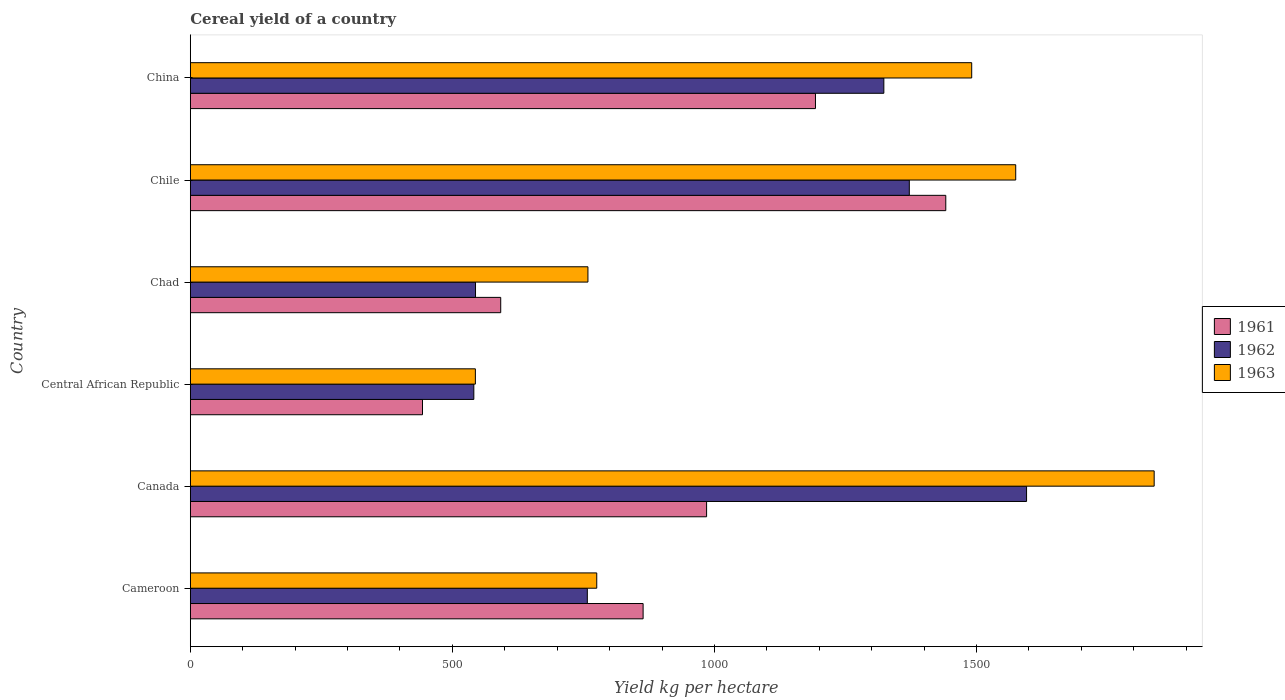How many different coloured bars are there?
Offer a very short reply. 3. How many groups of bars are there?
Your response must be concise. 6. Are the number of bars per tick equal to the number of legend labels?
Your response must be concise. Yes. How many bars are there on the 5th tick from the top?
Offer a terse response. 3. What is the label of the 3rd group of bars from the top?
Make the answer very short. Chad. What is the total cereal yield in 1961 in Chile?
Make the answer very short. 1441.31. Across all countries, what is the maximum total cereal yield in 1961?
Make the answer very short. 1441.31. Across all countries, what is the minimum total cereal yield in 1961?
Give a very brief answer. 443. In which country was the total cereal yield in 1962 minimum?
Your answer should be compact. Central African Republic. What is the total total cereal yield in 1963 in the graph?
Your answer should be very brief. 6982.22. What is the difference between the total cereal yield in 1963 in Cameroon and that in Central African Republic?
Provide a short and direct response. 231.56. What is the difference between the total cereal yield in 1961 in Central African Republic and the total cereal yield in 1962 in Canada?
Keep it short and to the point. -1152.42. What is the average total cereal yield in 1961 per country?
Provide a short and direct response. 919.68. What is the difference between the total cereal yield in 1961 and total cereal yield in 1963 in Canada?
Offer a very short reply. -853.88. In how many countries, is the total cereal yield in 1963 greater than 1800 kg per hectare?
Give a very brief answer. 1. What is the ratio of the total cereal yield in 1963 in Central African Republic to that in China?
Offer a very short reply. 0.36. Is the total cereal yield in 1962 in Chad less than that in China?
Ensure brevity in your answer.  Yes. Is the difference between the total cereal yield in 1961 in Chad and Chile greater than the difference between the total cereal yield in 1963 in Chad and Chile?
Give a very brief answer. No. What is the difference between the highest and the second highest total cereal yield in 1962?
Your answer should be compact. 223.68. What is the difference between the highest and the lowest total cereal yield in 1963?
Offer a very short reply. 1294.99. Is it the case that in every country, the sum of the total cereal yield in 1961 and total cereal yield in 1963 is greater than the total cereal yield in 1962?
Offer a terse response. Yes. How many bars are there?
Keep it short and to the point. 18. How many countries are there in the graph?
Your answer should be compact. 6. What is the difference between two consecutive major ticks on the X-axis?
Your answer should be compact. 500. Does the graph contain any zero values?
Ensure brevity in your answer.  No. Does the graph contain grids?
Provide a succinct answer. No. How are the legend labels stacked?
Your answer should be very brief. Vertical. What is the title of the graph?
Make the answer very short. Cereal yield of a country. Does "1994" appear as one of the legend labels in the graph?
Give a very brief answer. No. What is the label or title of the X-axis?
Provide a succinct answer. Yield kg per hectare. What is the Yield kg per hectare of 1961 in Cameroon?
Your response must be concise. 863.87. What is the Yield kg per hectare of 1962 in Cameroon?
Provide a short and direct response. 757.46. What is the Yield kg per hectare in 1963 in Cameroon?
Offer a terse response. 775.43. What is the Yield kg per hectare in 1961 in Canada?
Offer a very short reply. 984.99. What is the Yield kg per hectare in 1962 in Canada?
Make the answer very short. 1595.42. What is the Yield kg per hectare in 1963 in Canada?
Ensure brevity in your answer.  1838.86. What is the Yield kg per hectare in 1961 in Central African Republic?
Your answer should be compact. 443. What is the Yield kg per hectare of 1962 in Central African Republic?
Keep it short and to the point. 540.91. What is the Yield kg per hectare of 1963 in Central African Republic?
Give a very brief answer. 543.87. What is the Yield kg per hectare in 1961 in Chad?
Your answer should be very brief. 592.23. What is the Yield kg per hectare of 1962 in Chad?
Provide a succinct answer. 544.13. What is the Yield kg per hectare of 1963 in Chad?
Give a very brief answer. 758.6. What is the Yield kg per hectare of 1961 in Chile?
Make the answer very short. 1441.31. What is the Yield kg per hectare in 1962 in Chile?
Provide a succinct answer. 1371.74. What is the Yield kg per hectare in 1963 in Chile?
Your answer should be compact. 1574.71. What is the Yield kg per hectare in 1961 in China?
Your answer should be very brief. 1192.71. What is the Yield kg per hectare in 1962 in China?
Your answer should be compact. 1323.14. What is the Yield kg per hectare in 1963 in China?
Your response must be concise. 1490.74. Across all countries, what is the maximum Yield kg per hectare in 1961?
Make the answer very short. 1441.31. Across all countries, what is the maximum Yield kg per hectare in 1962?
Ensure brevity in your answer.  1595.42. Across all countries, what is the maximum Yield kg per hectare in 1963?
Your answer should be very brief. 1838.86. Across all countries, what is the minimum Yield kg per hectare of 1961?
Your response must be concise. 443. Across all countries, what is the minimum Yield kg per hectare of 1962?
Offer a very short reply. 540.91. Across all countries, what is the minimum Yield kg per hectare of 1963?
Give a very brief answer. 543.87. What is the total Yield kg per hectare in 1961 in the graph?
Your response must be concise. 5518.11. What is the total Yield kg per hectare in 1962 in the graph?
Offer a very short reply. 6132.79. What is the total Yield kg per hectare in 1963 in the graph?
Provide a succinct answer. 6982.23. What is the difference between the Yield kg per hectare in 1961 in Cameroon and that in Canada?
Offer a terse response. -121.12. What is the difference between the Yield kg per hectare in 1962 in Cameroon and that in Canada?
Offer a very short reply. -837.96. What is the difference between the Yield kg per hectare of 1963 in Cameroon and that in Canada?
Provide a short and direct response. -1063.44. What is the difference between the Yield kg per hectare in 1961 in Cameroon and that in Central African Republic?
Ensure brevity in your answer.  420.88. What is the difference between the Yield kg per hectare of 1962 in Cameroon and that in Central African Republic?
Provide a succinct answer. 216.55. What is the difference between the Yield kg per hectare of 1963 in Cameroon and that in Central African Republic?
Give a very brief answer. 231.56. What is the difference between the Yield kg per hectare of 1961 in Cameroon and that in Chad?
Keep it short and to the point. 271.64. What is the difference between the Yield kg per hectare of 1962 in Cameroon and that in Chad?
Offer a very short reply. 213.32. What is the difference between the Yield kg per hectare of 1963 in Cameroon and that in Chad?
Give a very brief answer. 16.82. What is the difference between the Yield kg per hectare in 1961 in Cameroon and that in Chile?
Keep it short and to the point. -577.43. What is the difference between the Yield kg per hectare of 1962 in Cameroon and that in Chile?
Your response must be concise. -614.28. What is the difference between the Yield kg per hectare in 1963 in Cameroon and that in Chile?
Your answer should be very brief. -799.29. What is the difference between the Yield kg per hectare of 1961 in Cameroon and that in China?
Provide a short and direct response. -328.83. What is the difference between the Yield kg per hectare of 1962 in Cameroon and that in China?
Offer a terse response. -565.68. What is the difference between the Yield kg per hectare of 1963 in Cameroon and that in China?
Keep it short and to the point. -715.32. What is the difference between the Yield kg per hectare of 1961 in Canada and that in Central African Republic?
Your response must be concise. 541.99. What is the difference between the Yield kg per hectare in 1962 in Canada and that in Central African Republic?
Your response must be concise. 1054.51. What is the difference between the Yield kg per hectare in 1963 in Canada and that in Central African Republic?
Offer a very short reply. 1294.99. What is the difference between the Yield kg per hectare of 1961 in Canada and that in Chad?
Your answer should be very brief. 392.76. What is the difference between the Yield kg per hectare of 1962 in Canada and that in Chad?
Your answer should be compact. 1051.29. What is the difference between the Yield kg per hectare in 1963 in Canada and that in Chad?
Your answer should be very brief. 1080.26. What is the difference between the Yield kg per hectare in 1961 in Canada and that in Chile?
Your answer should be very brief. -456.32. What is the difference between the Yield kg per hectare of 1962 in Canada and that in Chile?
Provide a short and direct response. 223.68. What is the difference between the Yield kg per hectare in 1963 in Canada and that in Chile?
Provide a succinct answer. 264.15. What is the difference between the Yield kg per hectare in 1961 in Canada and that in China?
Provide a succinct answer. -207.72. What is the difference between the Yield kg per hectare of 1962 in Canada and that in China?
Your response must be concise. 272.28. What is the difference between the Yield kg per hectare in 1963 in Canada and that in China?
Ensure brevity in your answer.  348.12. What is the difference between the Yield kg per hectare in 1961 in Central African Republic and that in Chad?
Ensure brevity in your answer.  -149.24. What is the difference between the Yield kg per hectare in 1962 in Central African Republic and that in Chad?
Keep it short and to the point. -3.22. What is the difference between the Yield kg per hectare of 1963 in Central African Republic and that in Chad?
Offer a terse response. -214.73. What is the difference between the Yield kg per hectare of 1961 in Central African Republic and that in Chile?
Give a very brief answer. -998.31. What is the difference between the Yield kg per hectare of 1962 in Central African Republic and that in Chile?
Ensure brevity in your answer.  -830.83. What is the difference between the Yield kg per hectare in 1963 in Central African Republic and that in Chile?
Your answer should be very brief. -1030.84. What is the difference between the Yield kg per hectare of 1961 in Central African Republic and that in China?
Give a very brief answer. -749.71. What is the difference between the Yield kg per hectare of 1962 in Central African Republic and that in China?
Your answer should be very brief. -782.23. What is the difference between the Yield kg per hectare of 1963 in Central African Republic and that in China?
Keep it short and to the point. -946.87. What is the difference between the Yield kg per hectare of 1961 in Chad and that in Chile?
Your answer should be very brief. -849.08. What is the difference between the Yield kg per hectare of 1962 in Chad and that in Chile?
Make the answer very short. -827.61. What is the difference between the Yield kg per hectare in 1963 in Chad and that in Chile?
Your answer should be very brief. -816.11. What is the difference between the Yield kg per hectare in 1961 in Chad and that in China?
Your answer should be very brief. -600.47. What is the difference between the Yield kg per hectare in 1962 in Chad and that in China?
Your answer should be compact. -779. What is the difference between the Yield kg per hectare in 1963 in Chad and that in China?
Offer a very short reply. -732.14. What is the difference between the Yield kg per hectare in 1961 in Chile and that in China?
Offer a very short reply. 248.6. What is the difference between the Yield kg per hectare of 1962 in Chile and that in China?
Provide a succinct answer. 48.6. What is the difference between the Yield kg per hectare in 1963 in Chile and that in China?
Give a very brief answer. 83.97. What is the difference between the Yield kg per hectare of 1961 in Cameroon and the Yield kg per hectare of 1962 in Canada?
Your answer should be very brief. -731.54. What is the difference between the Yield kg per hectare in 1961 in Cameroon and the Yield kg per hectare in 1963 in Canada?
Your answer should be compact. -974.99. What is the difference between the Yield kg per hectare of 1962 in Cameroon and the Yield kg per hectare of 1963 in Canada?
Give a very brief answer. -1081.41. What is the difference between the Yield kg per hectare of 1961 in Cameroon and the Yield kg per hectare of 1962 in Central African Republic?
Make the answer very short. 322.96. What is the difference between the Yield kg per hectare in 1961 in Cameroon and the Yield kg per hectare in 1963 in Central African Republic?
Provide a succinct answer. 320. What is the difference between the Yield kg per hectare in 1962 in Cameroon and the Yield kg per hectare in 1963 in Central African Republic?
Provide a succinct answer. 213.58. What is the difference between the Yield kg per hectare of 1961 in Cameroon and the Yield kg per hectare of 1962 in Chad?
Your response must be concise. 319.74. What is the difference between the Yield kg per hectare of 1961 in Cameroon and the Yield kg per hectare of 1963 in Chad?
Provide a short and direct response. 105.27. What is the difference between the Yield kg per hectare in 1962 in Cameroon and the Yield kg per hectare in 1963 in Chad?
Your answer should be compact. -1.15. What is the difference between the Yield kg per hectare in 1961 in Cameroon and the Yield kg per hectare in 1962 in Chile?
Give a very brief answer. -507.87. What is the difference between the Yield kg per hectare in 1961 in Cameroon and the Yield kg per hectare in 1963 in Chile?
Give a very brief answer. -710.84. What is the difference between the Yield kg per hectare in 1962 in Cameroon and the Yield kg per hectare in 1963 in Chile?
Your answer should be compact. -817.26. What is the difference between the Yield kg per hectare in 1961 in Cameroon and the Yield kg per hectare in 1962 in China?
Your answer should be very brief. -459.26. What is the difference between the Yield kg per hectare in 1961 in Cameroon and the Yield kg per hectare in 1963 in China?
Your response must be concise. -626.87. What is the difference between the Yield kg per hectare of 1962 in Cameroon and the Yield kg per hectare of 1963 in China?
Keep it short and to the point. -733.29. What is the difference between the Yield kg per hectare of 1961 in Canada and the Yield kg per hectare of 1962 in Central African Republic?
Offer a very short reply. 444.08. What is the difference between the Yield kg per hectare in 1961 in Canada and the Yield kg per hectare in 1963 in Central African Republic?
Provide a succinct answer. 441.12. What is the difference between the Yield kg per hectare in 1962 in Canada and the Yield kg per hectare in 1963 in Central African Republic?
Keep it short and to the point. 1051.55. What is the difference between the Yield kg per hectare in 1961 in Canada and the Yield kg per hectare in 1962 in Chad?
Offer a very short reply. 440.86. What is the difference between the Yield kg per hectare in 1961 in Canada and the Yield kg per hectare in 1963 in Chad?
Provide a succinct answer. 226.38. What is the difference between the Yield kg per hectare in 1962 in Canada and the Yield kg per hectare in 1963 in Chad?
Provide a short and direct response. 836.81. What is the difference between the Yield kg per hectare in 1961 in Canada and the Yield kg per hectare in 1962 in Chile?
Keep it short and to the point. -386.75. What is the difference between the Yield kg per hectare in 1961 in Canada and the Yield kg per hectare in 1963 in Chile?
Make the answer very short. -589.73. What is the difference between the Yield kg per hectare of 1962 in Canada and the Yield kg per hectare of 1963 in Chile?
Your response must be concise. 20.7. What is the difference between the Yield kg per hectare in 1961 in Canada and the Yield kg per hectare in 1962 in China?
Offer a very short reply. -338.15. What is the difference between the Yield kg per hectare of 1961 in Canada and the Yield kg per hectare of 1963 in China?
Offer a very short reply. -505.75. What is the difference between the Yield kg per hectare of 1962 in Canada and the Yield kg per hectare of 1963 in China?
Give a very brief answer. 104.67. What is the difference between the Yield kg per hectare in 1961 in Central African Republic and the Yield kg per hectare in 1962 in Chad?
Your response must be concise. -101.13. What is the difference between the Yield kg per hectare of 1961 in Central African Republic and the Yield kg per hectare of 1963 in Chad?
Provide a short and direct response. -315.61. What is the difference between the Yield kg per hectare in 1962 in Central African Republic and the Yield kg per hectare in 1963 in Chad?
Ensure brevity in your answer.  -217.69. What is the difference between the Yield kg per hectare in 1961 in Central African Republic and the Yield kg per hectare in 1962 in Chile?
Give a very brief answer. -928.74. What is the difference between the Yield kg per hectare of 1961 in Central African Republic and the Yield kg per hectare of 1963 in Chile?
Your answer should be very brief. -1131.72. What is the difference between the Yield kg per hectare of 1962 in Central African Republic and the Yield kg per hectare of 1963 in Chile?
Offer a very short reply. -1033.81. What is the difference between the Yield kg per hectare of 1961 in Central African Republic and the Yield kg per hectare of 1962 in China?
Your answer should be compact. -880.14. What is the difference between the Yield kg per hectare of 1961 in Central African Republic and the Yield kg per hectare of 1963 in China?
Your answer should be very brief. -1047.75. What is the difference between the Yield kg per hectare in 1962 in Central African Republic and the Yield kg per hectare in 1963 in China?
Make the answer very short. -949.84. What is the difference between the Yield kg per hectare in 1961 in Chad and the Yield kg per hectare in 1962 in Chile?
Offer a very short reply. -779.5. What is the difference between the Yield kg per hectare of 1961 in Chad and the Yield kg per hectare of 1963 in Chile?
Provide a succinct answer. -982.48. What is the difference between the Yield kg per hectare of 1962 in Chad and the Yield kg per hectare of 1963 in Chile?
Give a very brief answer. -1030.58. What is the difference between the Yield kg per hectare in 1961 in Chad and the Yield kg per hectare in 1962 in China?
Offer a very short reply. -730.9. What is the difference between the Yield kg per hectare in 1961 in Chad and the Yield kg per hectare in 1963 in China?
Your answer should be very brief. -898.51. What is the difference between the Yield kg per hectare in 1962 in Chad and the Yield kg per hectare in 1963 in China?
Make the answer very short. -946.61. What is the difference between the Yield kg per hectare of 1961 in Chile and the Yield kg per hectare of 1962 in China?
Your response must be concise. 118.17. What is the difference between the Yield kg per hectare in 1961 in Chile and the Yield kg per hectare in 1963 in China?
Ensure brevity in your answer.  -49.44. What is the difference between the Yield kg per hectare in 1962 in Chile and the Yield kg per hectare in 1963 in China?
Ensure brevity in your answer.  -119.01. What is the average Yield kg per hectare of 1961 per country?
Give a very brief answer. 919.68. What is the average Yield kg per hectare in 1962 per country?
Offer a very short reply. 1022.13. What is the average Yield kg per hectare of 1963 per country?
Give a very brief answer. 1163.7. What is the difference between the Yield kg per hectare of 1961 and Yield kg per hectare of 1962 in Cameroon?
Your answer should be compact. 106.42. What is the difference between the Yield kg per hectare of 1961 and Yield kg per hectare of 1963 in Cameroon?
Ensure brevity in your answer.  88.44. What is the difference between the Yield kg per hectare in 1962 and Yield kg per hectare in 1963 in Cameroon?
Your response must be concise. -17.97. What is the difference between the Yield kg per hectare of 1961 and Yield kg per hectare of 1962 in Canada?
Your answer should be compact. -610.43. What is the difference between the Yield kg per hectare of 1961 and Yield kg per hectare of 1963 in Canada?
Offer a very short reply. -853.88. What is the difference between the Yield kg per hectare in 1962 and Yield kg per hectare in 1963 in Canada?
Provide a succinct answer. -243.45. What is the difference between the Yield kg per hectare in 1961 and Yield kg per hectare in 1962 in Central African Republic?
Provide a short and direct response. -97.91. What is the difference between the Yield kg per hectare of 1961 and Yield kg per hectare of 1963 in Central African Republic?
Offer a very short reply. -100.87. What is the difference between the Yield kg per hectare in 1962 and Yield kg per hectare in 1963 in Central African Republic?
Provide a succinct answer. -2.96. What is the difference between the Yield kg per hectare of 1961 and Yield kg per hectare of 1962 in Chad?
Your answer should be very brief. 48.1. What is the difference between the Yield kg per hectare of 1961 and Yield kg per hectare of 1963 in Chad?
Give a very brief answer. -166.37. What is the difference between the Yield kg per hectare in 1962 and Yield kg per hectare in 1963 in Chad?
Provide a short and direct response. -214.47. What is the difference between the Yield kg per hectare in 1961 and Yield kg per hectare in 1962 in Chile?
Provide a short and direct response. 69.57. What is the difference between the Yield kg per hectare of 1961 and Yield kg per hectare of 1963 in Chile?
Ensure brevity in your answer.  -133.41. What is the difference between the Yield kg per hectare of 1962 and Yield kg per hectare of 1963 in Chile?
Ensure brevity in your answer.  -202.98. What is the difference between the Yield kg per hectare of 1961 and Yield kg per hectare of 1962 in China?
Your answer should be very brief. -130.43. What is the difference between the Yield kg per hectare of 1961 and Yield kg per hectare of 1963 in China?
Your response must be concise. -298.04. What is the difference between the Yield kg per hectare of 1962 and Yield kg per hectare of 1963 in China?
Offer a terse response. -167.61. What is the ratio of the Yield kg per hectare of 1961 in Cameroon to that in Canada?
Your response must be concise. 0.88. What is the ratio of the Yield kg per hectare in 1962 in Cameroon to that in Canada?
Your answer should be very brief. 0.47. What is the ratio of the Yield kg per hectare in 1963 in Cameroon to that in Canada?
Offer a terse response. 0.42. What is the ratio of the Yield kg per hectare of 1961 in Cameroon to that in Central African Republic?
Ensure brevity in your answer.  1.95. What is the ratio of the Yield kg per hectare of 1962 in Cameroon to that in Central African Republic?
Provide a short and direct response. 1.4. What is the ratio of the Yield kg per hectare in 1963 in Cameroon to that in Central African Republic?
Make the answer very short. 1.43. What is the ratio of the Yield kg per hectare in 1961 in Cameroon to that in Chad?
Make the answer very short. 1.46. What is the ratio of the Yield kg per hectare of 1962 in Cameroon to that in Chad?
Your answer should be very brief. 1.39. What is the ratio of the Yield kg per hectare of 1963 in Cameroon to that in Chad?
Keep it short and to the point. 1.02. What is the ratio of the Yield kg per hectare in 1961 in Cameroon to that in Chile?
Keep it short and to the point. 0.6. What is the ratio of the Yield kg per hectare of 1962 in Cameroon to that in Chile?
Ensure brevity in your answer.  0.55. What is the ratio of the Yield kg per hectare of 1963 in Cameroon to that in Chile?
Provide a succinct answer. 0.49. What is the ratio of the Yield kg per hectare of 1961 in Cameroon to that in China?
Keep it short and to the point. 0.72. What is the ratio of the Yield kg per hectare of 1962 in Cameroon to that in China?
Ensure brevity in your answer.  0.57. What is the ratio of the Yield kg per hectare in 1963 in Cameroon to that in China?
Offer a terse response. 0.52. What is the ratio of the Yield kg per hectare in 1961 in Canada to that in Central African Republic?
Ensure brevity in your answer.  2.22. What is the ratio of the Yield kg per hectare of 1962 in Canada to that in Central African Republic?
Provide a succinct answer. 2.95. What is the ratio of the Yield kg per hectare of 1963 in Canada to that in Central African Republic?
Your answer should be very brief. 3.38. What is the ratio of the Yield kg per hectare in 1961 in Canada to that in Chad?
Keep it short and to the point. 1.66. What is the ratio of the Yield kg per hectare of 1962 in Canada to that in Chad?
Your answer should be compact. 2.93. What is the ratio of the Yield kg per hectare in 1963 in Canada to that in Chad?
Provide a short and direct response. 2.42. What is the ratio of the Yield kg per hectare in 1961 in Canada to that in Chile?
Your answer should be compact. 0.68. What is the ratio of the Yield kg per hectare of 1962 in Canada to that in Chile?
Give a very brief answer. 1.16. What is the ratio of the Yield kg per hectare of 1963 in Canada to that in Chile?
Keep it short and to the point. 1.17. What is the ratio of the Yield kg per hectare in 1961 in Canada to that in China?
Your answer should be compact. 0.83. What is the ratio of the Yield kg per hectare of 1962 in Canada to that in China?
Offer a terse response. 1.21. What is the ratio of the Yield kg per hectare of 1963 in Canada to that in China?
Offer a terse response. 1.23. What is the ratio of the Yield kg per hectare in 1961 in Central African Republic to that in Chad?
Make the answer very short. 0.75. What is the ratio of the Yield kg per hectare of 1962 in Central African Republic to that in Chad?
Offer a very short reply. 0.99. What is the ratio of the Yield kg per hectare of 1963 in Central African Republic to that in Chad?
Your answer should be compact. 0.72. What is the ratio of the Yield kg per hectare of 1961 in Central African Republic to that in Chile?
Your response must be concise. 0.31. What is the ratio of the Yield kg per hectare of 1962 in Central African Republic to that in Chile?
Provide a short and direct response. 0.39. What is the ratio of the Yield kg per hectare in 1963 in Central African Republic to that in Chile?
Your response must be concise. 0.35. What is the ratio of the Yield kg per hectare of 1961 in Central African Republic to that in China?
Offer a very short reply. 0.37. What is the ratio of the Yield kg per hectare in 1962 in Central African Republic to that in China?
Keep it short and to the point. 0.41. What is the ratio of the Yield kg per hectare in 1963 in Central African Republic to that in China?
Offer a terse response. 0.36. What is the ratio of the Yield kg per hectare in 1961 in Chad to that in Chile?
Ensure brevity in your answer.  0.41. What is the ratio of the Yield kg per hectare in 1962 in Chad to that in Chile?
Make the answer very short. 0.4. What is the ratio of the Yield kg per hectare of 1963 in Chad to that in Chile?
Your answer should be very brief. 0.48. What is the ratio of the Yield kg per hectare of 1961 in Chad to that in China?
Ensure brevity in your answer.  0.5. What is the ratio of the Yield kg per hectare in 1962 in Chad to that in China?
Make the answer very short. 0.41. What is the ratio of the Yield kg per hectare of 1963 in Chad to that in China?
Make the answer very short. 0.51. What is the ratio of the Yield kg per hectare in 1961 in Chile to that in China?
Make the answer very short. 1.21. What is the ratio of the Yield kg per hectare of 1962 in Chile to that in China?
Provide a short and direct response. 1.04. What is the ratio of the Yield kg per hectare of 1963 in Chile to that in China?
Your response must be concise. 1.06. What is the difference between the highest and the second highest Yield kg per hectare of 1961?
Provide a short and direct response. 248.6. What is the difference between the highest and the second highest Yield kg per hectare of 1962?
Provide a succinct answer. 223.68. What is the difference between the highest and the second highest Yield kg per hectare of 1963?
Your answer should be compact. 264.15. What is the difference between the highest and the lowest Yield kg per hectare of 1961?
Offer a terse response. 998.31. What is the difference between the highest and the lowest Yield kg per hectare in 1962?
Provide a short and direct response. 1054.51. What is the difference between the highest and the lowest Yield kg per hectare in 1963?
Ensure brevity in your answer.  1294.99. 